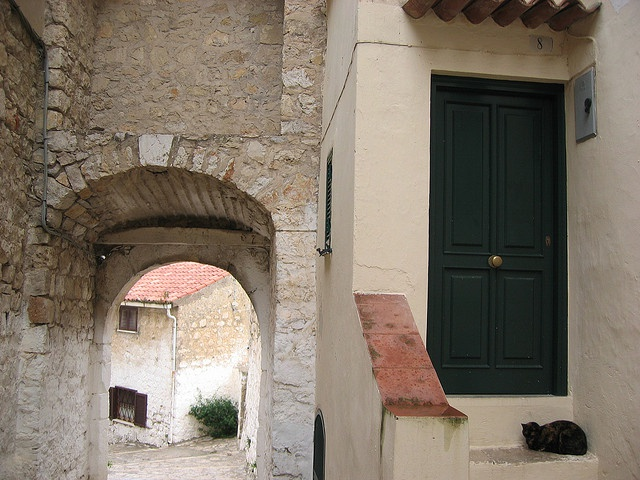Describe the objects in this image and their specific colors. I can see a cat in black, gray, and maroon tones in this image. 